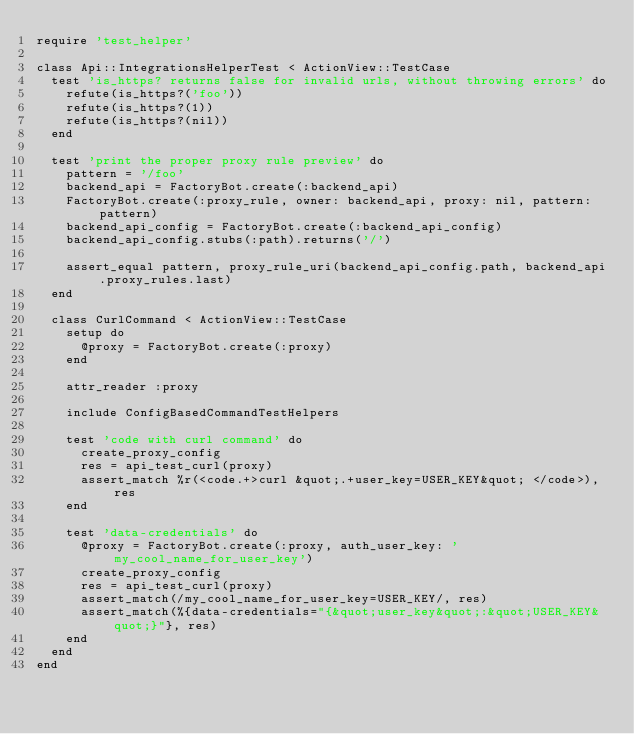Convert code to text. <code><loc_0><loc_0><loc_500><loc_500><_Ruby_>require 'test_helper'

class Api::IntegrationsHelperTest < ActionView::TestCase
  test 'is_https? returns false for invalid urls, without throwing errors' do
    refute(is_https?('foo'))
    refute(is_https?(1))
    refute(is_https?(nil))
  end

  test 'print the proper proxy rule preview' do
    pattern = '/foo'
    backend_api = FactoryBot.create(:backend_api)
    FactoryBot.create(:proxy_rule, owner: backend_api, proxy: nil, pattern: pattern)
    backend_api_config = FactoryBot.create(:backend_api_config)
    backend_api_config.stubs(:path).returns('/')

    assert_equal pattern, proxy_rule_uri(backend_api_config.path, backend_api.proxy_rules.last)
  end

  class CurlCommand < ActionView::TestCase
    setup do
      @proxy = FactoryBot.create(:proxy)
    end

    attr_reader :proxy

    include ConfigBasedCommandTestHelpers

    test 'code with curl command' do
      create_proxy_config
      res = api_test_curl(proxy)
      assert_match %r(<code.+>curl &quot;.+user_key=USER_KEY&quot; </code>), res
    end

    test 'data-credentials' do
      @proxy = FactoryBot.create(:proxy, auth_user_key: 'my_cool_name_for_user_key')
      create_proxy_config
      res = api_test_curl(proxy)
      assert_match(/my_cool_name_for_user_key=USER_KEY/, res)
      assert_match(%{data-credentials="{&quot;user_key&quot;:&quot;USER_KEY&quot;}"}, res)
    end
  end
end
</code> 